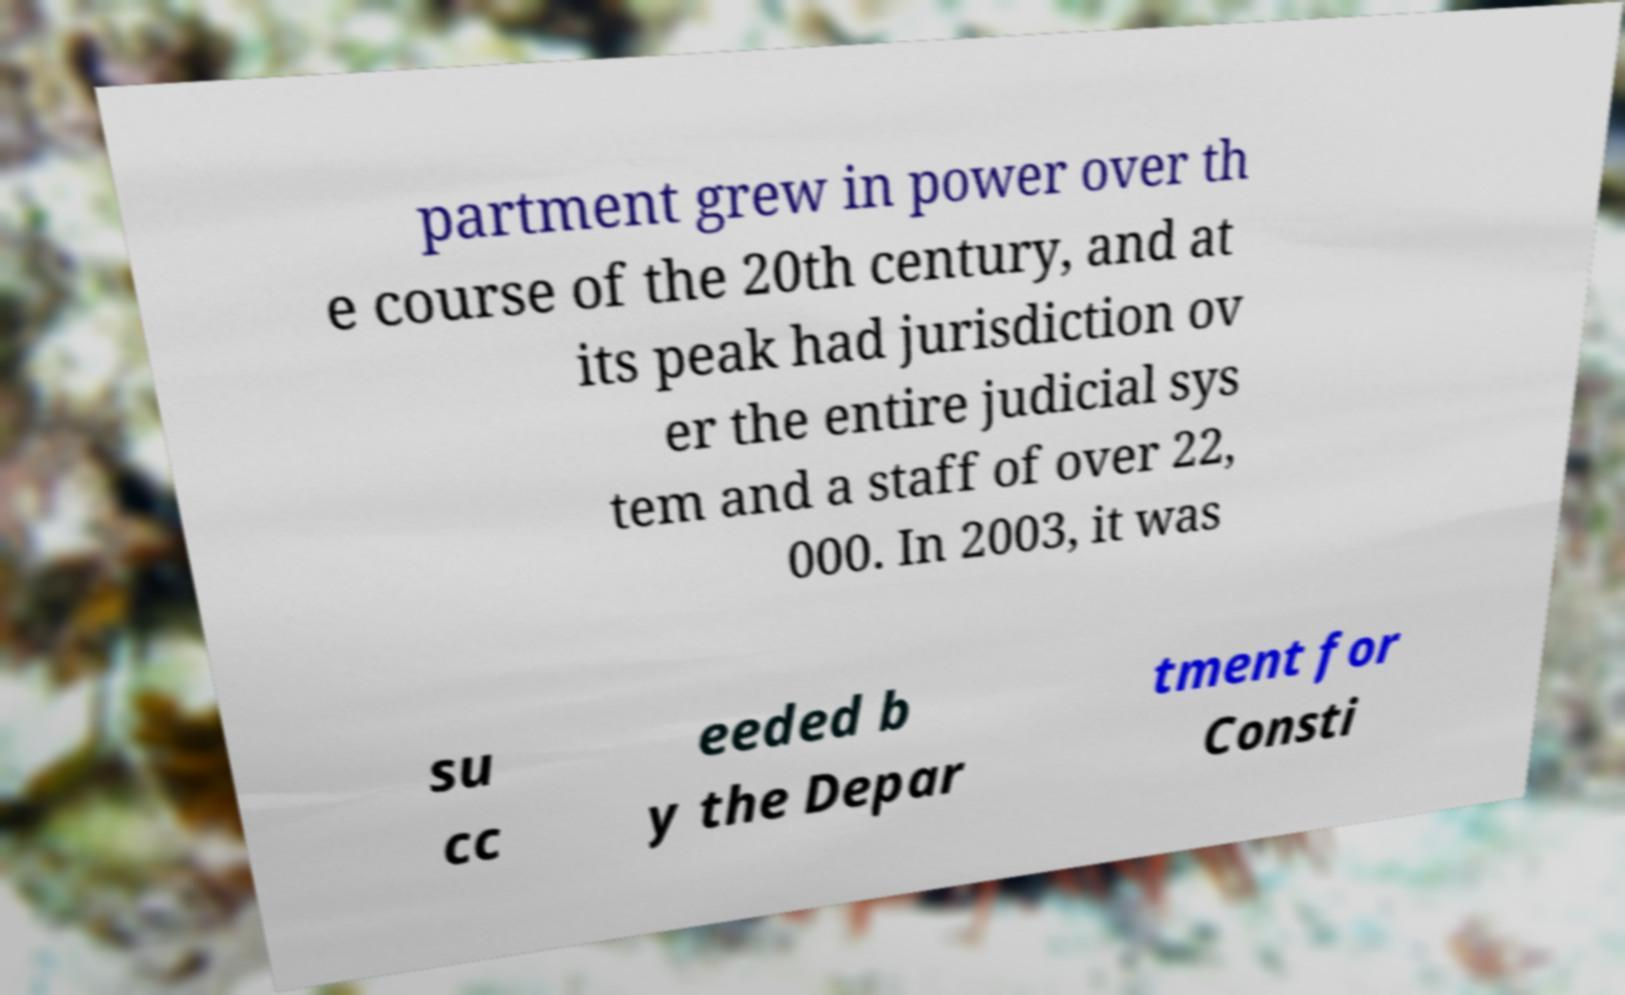Please identify and transcribe the text found in this image. partment grew in power over th e course of the 20th century, and at its peak had jurisdiction ov er the entire judicial sys tem and a staff of over 22, 000. In 2003, it was su cc eeded b y the Depar tment for Consti 